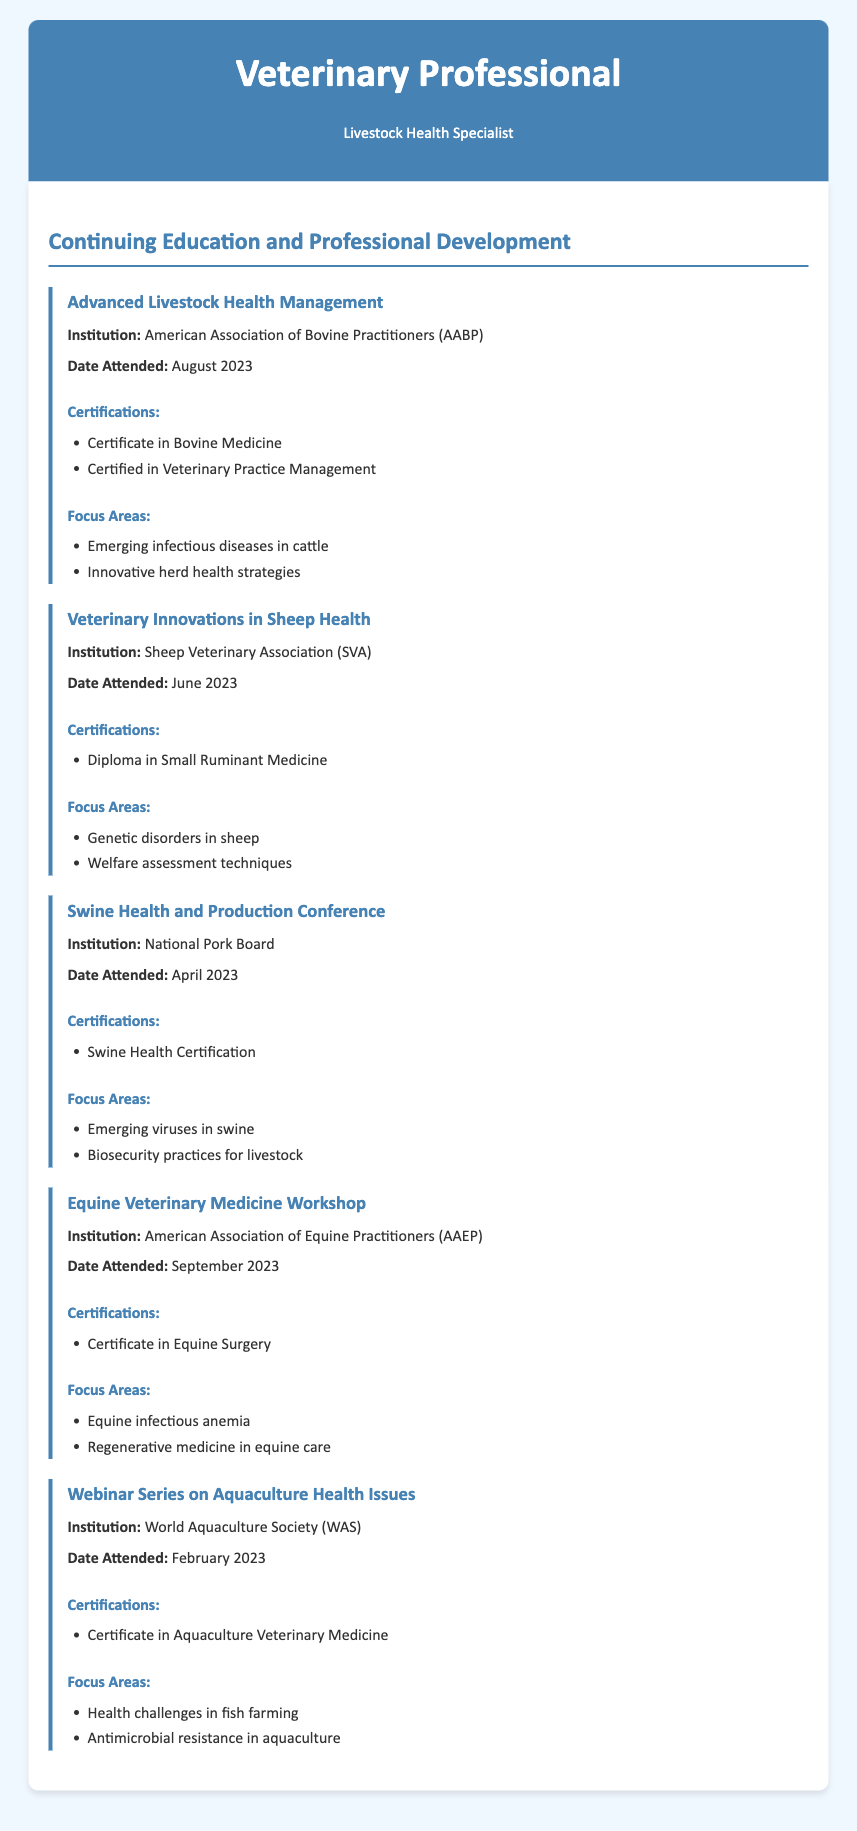What is the title of the first program attended? The title of the first program attended, listed in the document, is "Advanced Livestock Health Management."
Answer: Advanced Livestock Health Management Which institution hosted the Swine Health and Production Conference? The institution that hosted the Swine Health and Production Conference is mentioned as the National Pork Board in the document.
Answer: National Pork Board What certification was obtained from the Veterinary Innovations in Sheep Health program? The certification obtained from the Veterinary Innovations in Sheep Health program is detailed as a "Diploma in Small Ruminant Medicine."
Answer: Diploma in Small Ruminant Medicine How many certifications were obtained from the Advanced Livestock Health Management program? The document states that two certifications were obtained from the Advanced Livestock Health Management program: "Certificate in Bovine Medicine" and "Certified in Veterinary Practice Management."
Answer: Two Which emerging issue was a focus area of the webinar series on aquaculture health? The document highlights "Antimicrobial resistance in aquaculture" as one of the focus areas discussed in the webinar series on aquaculture health issues.
Answer: Antimicrobial resistance in aquaculture When was the Equine Veterinary Medicine Workshop attended? The date when the Equine Veterinary Medicine Workshop was attended is shown in the document as September 2023.
Answer: September 2023 What was a key focus area of the Swine Health and Production Conference? The document mentions "Emerging viruses in swine" as a key focus area of the Swine Health and Production Conference.
Answer: Emerging viruses in swine How many total professional development programs are listed in the document? The document lists a total of five professional development programs attended.
Answer: Five 